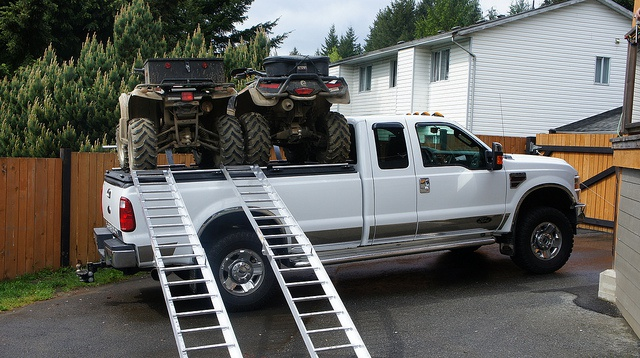Describe the objects in this image and their specific colors. I can see a truck in black, darkgray, lightgray, and gray tones in this image. 